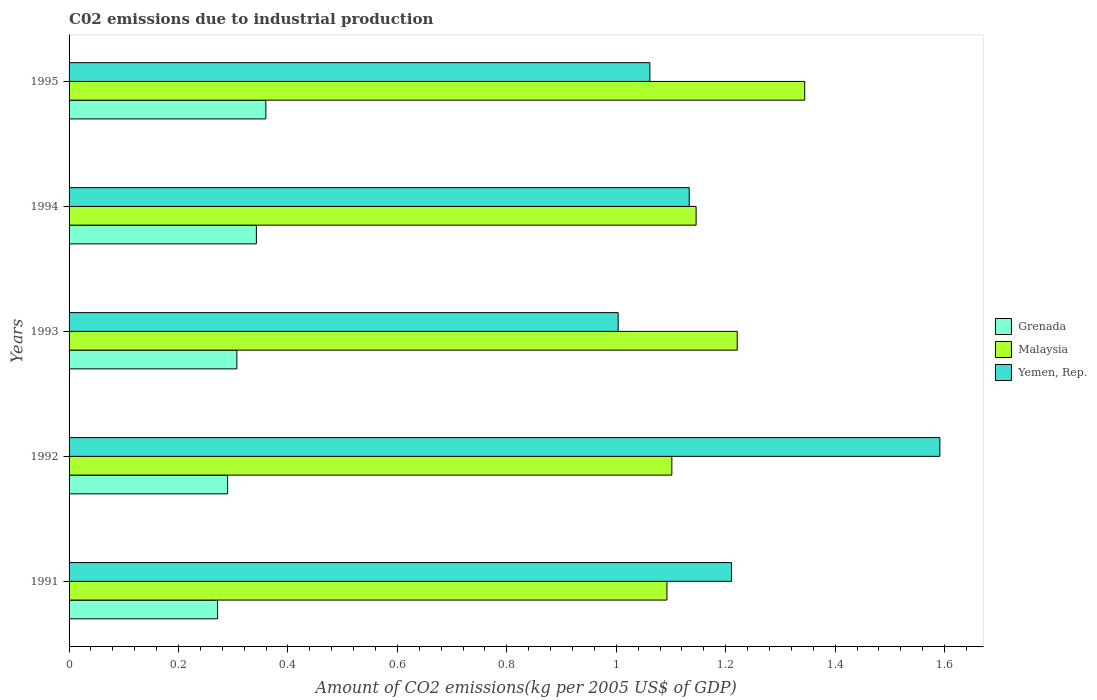Are the number of bars on each tick of the Y-axis equal?
Your answer should be compact. Yes. How many bars are there on the 1st tick from the top?
Your response must be concise. 3. What is the label of the 3rd group of bars from the top?
Provide a short and direct response. 1993. In how many cases, is the number of bars for a given year not equal to the number of legend labels?
Offer a terse response. 0. What is the amount of CO2 emitted due to industrial production in Grenada in 1994?
Offer a very short reply. 0.34. Across all years, what is the maximum amount of CO2 emitted due to industrial production in Yemen, Rep.?
Offer a terse response. 1.59. Across all years, what is the minimum amount of CO2 emitted due to industrial production in Malaysia?
Provide a short and direct response. 1.09. In which year was the amount of CO2 emitted due to industrial production in Yemen, Rep. maximum?
Your answer should be compact. 1992. What is the total amount of CO2 emitted due to industrial production in Grenada in the graph?
Offer a terse response. 1.57. What is the difference between the amount of CO2 emitted due to industrial production in Yemen, Rep. in 1992 and that in 1994?
Keep it short and to the point. 0.46. What is the difference between the amount of CO2 emitted due to industrial production in Grenada in 1993 and the amount of CO2 emitted due to industrial production in Malaysia in 1991?
Offer a terse response. -0.79. What is the average amount of CO2 emitted due to industrial production in Yemen, Rep. per year?
Your answer should be compact. 1.2. In the year 1995, what is the difference between the amount of CO2 emitted due to industrial production in Yemen, Rep. and amount of CO2 emitted due to industrial production in Grenada?
Make the answer very short. 0.7. What is the ratio of the amount of CO2 emitted due to industrial production in Grenada in 1992 to that in 1993?
Keep it short and to the point. 0.94. What is the difference between the highest and the second highest amount of CO2 emitted due to industrial production in Malaysia?
Keep it short and to the point. 0.12. What is the difference between the highest and the lowest amount of CO2 emitted due to industrial production in Malaysia?
Your response must be concise. 0.25. Is the sum of the amount of CO2 emitted due to industrial production in Grenada in 1992 and 1994 greater than the maximum amount of CO2 emitted due to industrial production in Yemen, Rep. across all years?
Make the answer very short. No. What does the 2nd bar from the top in 1995 represents?
Provide a succinct answer. Malaysia. What does the 3rd bar from the bottom in 1991 represents?
Offer a very short reply. Yemen, Rep. Is it the case that in every year, the sum of the amount of CO2 emitted due to industrial production in Malaysia and amount of CO2 emitted due to industrial production in Yemen, Rep. is greater than the amount of CO2 emitted due to industrial production in Grenada?
Give a very brief answer. Yes. How many bars are there?
Your answer should be compact. 15. How many years are there in the graph?
Your response must be concise. 5. Are the values on the major ticks of X-axis written in scientific E-notation?
Give a very brief answer. No. Does the graph contain any zero values?
Ensure brevity in your answer.  No. Where does the legend appear in the graph?
Offer a terse response. Center right. How are the legend labels stacked?
Provide a succinct answer. Vertical. What is the title of the graph?
Provide a short and direct response. C02 emissions due to industrial production. What is the label or title of the X-axis?
Ensure brevity in your answer.  Amount of CO2 emissions(kg per 2005 US$ of GDP). What is the Amount of CO2 emissions(kg per 2005 US$ of GDP) in Grenada in 1991?
Your answer should be compact. 0.27. What is the Amount of CO2 emissions(kg per 2005 US$ of GDP) of Malaysia in 1991?
Make the answer very short. 1.09. What is the Amount of CO2 emissions(kg per 2005 US$ of GDP) in Yemen, Rep. in 1991?
Your answer should be very brief. 1.21. What is the Amount of CO2 emissions(kg per 2005 US$ of GDP) of Grenada in 1992?
Give a very brief answer. 0.29. What is the Amount of CO2 emissions(kg per 2005 US$ of GDP) of Malaysia in 1992?
Your answer should be compact. 1.1. What is the Amount of CO2 emissions(kg per 2005 US$ of GDP) of Yemen, Rep. in 1992?
Give a very brief answer. 1.59. What is the Amount of CO2 emissions(kg per 2005 US$ of GDP) of Grenada in 1993?
Ensure brevity in your answer.  0.31. What is the Amount of CO2 emissions(kg per 2005 US$ of GDP) in Malaysia in 1993?
Provide a succinct answer. 1.22. What is the Amount of CO2 emissions(kg per 2005 US$ of GDP) in Yemen, Rep. in 1993?
Offer a terse response. 1. What is the Amount of CO2 emissions(kg per 2005 US$ of GDP) in Grenada in 1994?
Offer a very short reply. 0.34. What is the Amount of CO2 emissions(kg per 2005 US$ of GDP) in Malaysia in 1994?
Make the answer very short. 1.15. What is the Amount of CO2 emissions(kg per 2005 US$ of GDP) of Yemen, Rep. in 1994?
Your answer should be very brief. 1.13. What is the Amount of CO2 emissions(kg per 2005 US$ of GDP) of Grenada in 1995?
Ensure brevity in your answer.  0.36. What is the Amount of CO2 emissions(kg per 2005 US$ of GDP) in Malaysia in 1995?
Offer a terse response. 1.34. What is the Amount of CO2 emissions(kg per 2005 US$ of GDP) of Yemen, Rep. in 1995?
Your answer should be very brief. 1.06. Across all years, what is the maximum Amount of CO2 emissions(kg per 2005 US$ of GDP) in Grenada?
Your response must be concise. 0.36. Across all years, what is the maximum Amount of CO2 emissions(kg per 2005 US$ of GDP) in Malaysia?
Your response must be concise. 1.34. Across all years, what is the maximum Amount of CO2 emissions(kg per 2005 US$ of GDP) of Yemen, Rep.?
Keep it short and to the point. 1.59. Across all years, what is the minimum Amount of CO2 emissions(kg per 2005 US$ of GDP) in Grenada?
Keep it short and to the point. 0.27. Across all years, what is the minimum Amount of CO2 emissions(kg per 2005 US$ of GDP) in Malaysia?
Your response must be concise. 1.09. Across all years, what is the minimum Amount of CO2 emissions(kg per 2005 US$ of GDP) in Yemen, Rep.?
Ensure brevity in your answer.  1. What is the total Amount of CO2 emissions(kg per 2005 US$ of GDP) of Grenada in the graph?
Your response must be concise. 1.57. What is the total Amount of CO2 emissions(kg per 2005 US$ of GDP) in Malaysia in the graph?
Ensure brevity in your answer.  5.91. What is the total Amount of CO2 emissions(kg per 2005 US$ of GDP) of Yemen, Rep. in the graph?
Make the answer very short. 6. What is the difference between the Amount of CO2 emissions(kg per 2005 US$ of GDP) of Grenada in 1991 and that in 1992?
Your answer should be compact. -0.02. What is the difference between the Amount of CO2 emissions(kg per 2005 US$ of GDP) in Malaysia in 1991 and that in 1992?
Your answer should be very brief. -0.01. What is the difference between the Amount of CO2 emissions(kg per 2005 US$ of GDP) in Yemen, Rep. in 1991 and that in 1992?
Keep it short and to the point. -0.38. What is the difference between the Amount of CO2 emissions(kg per 2005 US$ of GDP) in Grenada in 1991 and that in 1993?
Provide a short and direct response. -0.04. What is the difference between the Amount of CO2 emissions(kg per 2005 US$ of GDP) of Malaysia in 1991 and that in 1993?
Provide a succinct answer. -0.13. What is the difference between the Amount of CO2 emissions(kg per 2005 US$ of GDP) of Yemen, Rep. in 1991 and that in 1993?
Make the answer very short. 0.21. What is the difference between the Amount of CO2 emissions(kg per 2005 US$ of GDP) in Grenada in 1991 and that in 1994?
Keep it short and to the point. -0.07. What is the difference between the Amount of CO2 emissions(kg per 2005 US$ of GDP) in Malaysia in 1991 and that in 1994?
Ensure brevity in your answer.  -0.05. What is the difference between the Amount of CO2 emissions(kg per 2005 US$ of GDP) in Yemen, Rep. in 1991 and that in 1994?
Your answer should be very brief. 0.08. What is the difference between the Amount of CO2 emissions(kg per 2005 US$ of GDP) in Grenada in 1991 and that in 1995?
Your response must be concise. -0.09. What is the difference between the Amount of CO2 emissions(kg per 2005 US$ of GDP) of Malaysia in 1991 and that in 1995?
Your response must be concise. -0.25. What is the difference between the Amount of CO2 emissions(kg per 2005 US$ of GDP) in Yemen, Rep. in 1991 and that in 1995?
Provide a succinct answer. 0.15. What is the difference between the Amount of CO2 emissions(kg per 2005 US$ of GDP) of Grenada in 1992 and that in 1993?
Give a very brief answer. -0.02. What is the difference between the Amount of CO2 emissions(kg per 2005 US$ of GDP) in Malaysia in 1992 and that in 1993?
Offer a very short reply. -0.12. What is the difference between the Amount of CO2 emissions(kg per 2005 US$ of GDP) of Yemen, Rep. in 1992 and that in 1993?
Ensure brevity in your answer.  0.59. What is the difference between the Amount of CO2 emissions(kg per 2005 US$ of GDP) of Grenada in 1992 and that in 1994?
Offer a very short reply. -0.05. What is the difference between the Amount of CO2 emissions(kg per 2005 US$ of GDP) in Malaysia in 1992 and that in 1994?
Your answer should be very brief. -0.04. What is the difference between the Amount of CO2 emissions(kg per 2005 US$ of GDP) in Yemen, Rep. in 1992 and that in 1994?
Your response must be concise. 0.46. What is the difference between the Amount of CO2 emissions(kg per 2005 US$ of GDP) of Grenada in 1992 and that in 1995?
Give a very brief answer. -0.07. What is the difference between the Amount of CO2 emissions(kg per 2005 US$ of GDP) in Malaysia in 1992 and that in 1995?
Offer a very short reply. -0.24. What is the difference between the Amount of CO2 emissions(kg per 2005 US$ of GDP) of Yemen, Rep. in 1992 and that in 1995?
Keep it short and to the point. 0.53. What is the difference between the Amount of CO2 emissions(kg per 2005 US$ of GDP) in Grenada in 1993 and that in 1994?
Your answer should be compact. -0.04. What is the difference between the Amount of CO2 emissions(kg per 2005 US$ of GDP) in Malaysia in 1993 and that in 1994?
Your answer should be compact. 0.08. What is the difference between the Amount of CO2 emissions(kg per 2005 US$ of GDP) of Yemen, Rep. in 1993 and that in 1994?
Provide a succinct answer. -0.13. What is the difference between the Amount of CO2 emissions(kg per 2005 US$ of GDP) of Grenada in 1993 and that in 1995?
Offer a very short reply. -0.05. What is the difference between the Amount of CO2 emissions(kg per 2005 US$ of GDP) in Malaysia in 1993 and that in 1995?
Give a very brief answer. -0.12. What is the difference between the Amount of CO2 emissions(kg per 2005 US$ of GDP) of Yemen, Rep. in 1993 and that in 1995?
Make the answer very short. -0.06. What is the difference between the Amount of CO2 emissions(kg per 2005 US$ of GDP) of Grenada in 1994 and that in 1995?
Your answer should be very brief. -0.02. What is the difference between the Amount of CO2 emissions(kg per 2005 US$ of GDP) of Malaysia in 1994 and that in 1995?
Provide a short and direct response. -0.2. What is the difference between the Amount of CO2 emissions(kg per 2005 US$ of GDP) in Yemen, Rep. in 1994 and that in 1995?
Your response must be concise. 0.07. What is the difference between the Amount of CO2 emissions(kg per 2005 US$ of GDP) of Grenada in 1991 and the Amount of CO2 emissions(kg per 2005 US$ of GDP) of Malaysia in 1992?
Offer a terse response. -0.83. What is the difference between the Amount of CO2 emissions(kg per 2005 US$ of GDP) in Grenada in 1991 and the Amount of CO2 emissions(kg per 2005 US$ of GDP) in Yemen, Rep. in 1992?
Your response must be concise. -1.32. What is the difference between the Amount of CO2 emissions(kg per 2005 US$ of GDP) of Malaysia in 1991 and the Amount of CO2 emissions(kg per 2005 US$ of GDP) of Yemen, Rep. in 1992?
Your response must be concise. -0.5. What is the difference between the Amount of CO2 emissions(kg per 2005 US$ of GDP) in Grenada in 1991 and the Amount of CO2 emissions(kg per 2005 US$ of GDP) in Malaysia in 1993?
Your answer should be very brief. -0.95. What is the difference between the Amount of CO2 emissions(kg per 2005 US$ of GDP) of Grenada in 1991 and the Amount of CO2 emissions(kg per 2005 US$ of GDP) of Yemen, Rep. in 1993?
Your response must be concise. -0.73. What is the difference between the Amount of CO2 emissions(kg per 2005 US$ of GDP) in Malaysia in 1991 and the Amount of CO2 emissions(kg per 2005 US$ of GDP) in Yemen, Rep. in 1993?
Your answer should be compact. 0.09. What is the difference between the Amount of CO2 emissions(kg per 2005 US$ of GDP) in Grenada in 1991 and the Amount of CO2 emissions(kg per 2005 US$ of GDP) in Malaysia in 1994?
Provide a short and direct response. -0.87. What is the difference between the Amount of CO2 emissions(kg per 2005 US$ of GDP) in Grenada in 1991 and the Amount of CO2 emissions(kg per 2005 US$ of GDP) in Yemen, Rep. in 1994?
Your response must be concise. -0.86. What is the difference between the Amount of CO2 emissions(kg per 2005 US$ of GDP) in Malaysia in 1991 and the Amount of CO2 emissions(kg per 2005 US$ of GDP) in Yemen, Rep. in 1994?
Provide a short and direct response. -0.04. What is the difference between the Amount of CO2 emissions(kg per 2005 US$ of GDP) of Grenada in 1991 and the Amount of CO2 emissions(kg per 2005 US$ of GDP) of Malaysia in 1995?
Your answer should be very brief. -1.07. What is the difference between the Amount of CO2 emissions(kg per 2005 US$ of GDP) in Grenada in 1991 and the Amount of CO2 emissions(kg per 2005 US$ of GDP) in Yemen, Rep. in 1995?
Offer a very short reply. -0.79. What is the difference between the Amount of CO2 emissions(kg per 2005 US$ of GDP) of Malaysia in 1991 and the Amount of CO2 emissions(kg per 2005 US$ of GDP) of Yemen, Rep. in 1995?
Make the answer very short. 0.03. What is the difference between the Amount of CO2 emissions(kg per 2005 US$ of GDP) in Grenada in 1992 and the Amount of CO2 emissions(kg per 2005 US$ of GDP) in Malaysia in 1993?
Give a very brief answer. -0.93. What is the difference between the Amount of CO2 emissions(kg per 2005 US$ of GDP) in Grenada in 1992 and the Amount of CO2 emissions(kg per 2005 US$ of GDP) in Yemen, Rep. in 1993?
Offer a terse response. -0.71. What is the difference between the Amount of CO2 emissions(kg per 2005 US$ of GDP) in Malaysia in 1992 and the Amount of CO2 emissions(kg per 2005 US$ of GDP) in Yemen, Rep. in 1993?
Provide a short and direct response. 0.1. What is the difference between the Amount of CO2 emissions(kg per 2005 US$ of GDP) in Grenada in 1992 and the Amount of CO2 emissions(kg per 2005 US$ of GDP) in Malaysia in 1994?
Offer a terse response. -0.86. What is the difference between the Amount of CO2 emissions(kg per 2005 US$ of GDP) in Grenada in 1992 and the Amount of CO2 emissions(kg per 2005 US$ of GDP) in Yemen, Rep. in 1994?
Ensure brevity in your answer.  -0.84. What is the difference between the Amount of CO2 emissions(kg per 2005 US$ of GDP) in Malaysia in 1992 and the Amount of CO2 emissions(kg per 2005 US$ of GDP) in Yemen, Rep. in 1994?
Your response must be concise. -0.03. What is the difference between the Amount of CO2 emissions(kg per 2005 US$ of GDP) in Grenada in 1992 and the Amount of CO2 emissions(kg per 2005 US$ of GDP) in Malaysia in 1995?
Provide a succinct answer. -1.05. What is the difference between the Amount of CO2 emissions(kg per 2005 US$ of GDP) in Grenada in 1992 and the Amount of CO2 emissions(kg per 2005 US$ of GDP) in Yemen, Rep. in 1995?
Offer a terse response. -0.77. What is the difference between the Amount of CO2 emissions(kg per 2005 US$ of GDP) of Malaysia in 1992 and the Amount of CO2 emissions(kg per 2005 US$ of GDP) of Yemen, Rep. in 1995?
Give a very brief answer. 0.04. What is the difference between the Amount of CO2 emissions(kg per 2005 US$ of GDP) in Grenada in 1993 and the Amount of CO2 emissions(kg per 2005 US$ of GDP) in Malaysia in 1994?
Provide a short and direct response. -0.84. What is the difference between the Amount of CO2 emissions(kg per 2005 US$ of GDP) of Grenada in 1993 and the Amount of CO2 emissions(kg per 2005 US$ of GDP) of Yemen, Rep. in 1994?
Your response must be concise. -0.83. What is the difference between the Amount of CO2 emissions(kg per 2005 US$ of GDP) in Malaysia in 1993 and the Amount of CO2 emissions(kg per 2005 US$ of GDP) in Yemen, Rep. in 1994?
Make the answer very short. 0.09. What is the difference between the Amount of CO2 emissions(kg per 2005 US$ of GDP) in Grenada in 1993 and the Amount of CO2 emissions(kg per 2005 US$ of GDP) in Malaysia in 1995?
Your answer should be very brief. -1.04. What is the difference between the Amount of CO2 emissions(kg per 2005 US$ of GDP) in Grenada in 1993 and the Amount of CO2 emissions(kg per 2005 US$ of GDP) in Yemen, Rep. in 1995?
Offer a very short reply. -0.75. What is the difference between the Amount of CO2 emissions(kg per 2005 US$ of GDP) in Malaysia in 1993 and the Amount of CO2 emissions(kg per 2005 US$ of GDP) in Yemen, Rep. in 1995?
Provide a succinct answer. 0.16. What is the difference between the Amount of CO2 emissions(kg per 2005 US$ of GDP) of Grenada in 1994 and the Amount of CO2 emissions(kg per 2005 US$ of GDP) of Malaysia in 1995?
Make the answer very short. -1. What is the difference between the Amount of CO2 emissions(kg per 2005 US$ of GDP) of Grenada in 1994 and the Amount of CO2 emissions(kg per 2005 US$ of GDP) of Yemen, Rep. in 1995?
Offer a very short reply. -0.72. What is the difference between the Amount of CO2 emissions(kg per 2005 US$ of GDP) in Malaysia in 1994 and the Amount of CO2 emissions(kg per 2005 US$ of GDP) in Yemen, Rep. in 1995?
Provide a succinct answer. 0.08. What is the average Amount of CO2 emissions(kg per 2005 US$ of GDP) of Grenada per year?
Offer a very short reply. 0.31. What is the average Amount of CO2 emissions(kg per 2005 US$ of GDP) in Malaysia per year?
Ensure brevity in your answer.  1.18. What is the average Amount of CO2 emissions(kg per 2005 US$ of GDP) in Yemen, Rep. per year?
Keep it short and to the point. 1.2. In the year 1991, what is the difference between the Amount of CO2 emissions(kg per 2005 US$ of GDP) of Grenada and Amount of CO2 emissions(kg per 2005 US$ of GDP) of Malaysia?
Give a very brief answer. -0.82. In the year 1991, what is the difference between the Amount of CO2 emissions(kg per 2005 US$ of GDP) in Grenada and Amount of CO2 emissions(kg per 2005 US$ of GDP) in Yemen, Rep.?
Your answer should be very brief. -0.94. In the year 1991, what is the difference between the Amount of CO2 emissions(kg per 2005 US$ of GDP) in Malaysia and Amount of CO2 emissions(kg per 2005 US$ of GDP) in Yemen, Rep.?
Provide a succinct answer. -0.12. In the year 1992, what is the difference between the Amount of CO2 emissions(kg per 2005 US$ of GDP) of Grenada and Amount of CO2 emissions(kg per 2005 US$ of GDP) of Malaysia?
Give a very brief answer. -0.81. In the year 1992, what is the difference between the Amount of CO2 emissions(kg per 2005 US$ of GDP) in Grenada and Amount of CO2 emissions(kg per 2005 US$ of GDP) in Yemen, Rep.?
Provide a short and direct response. -1.3. In the year 1992, what is the difference between the Amount of CO2 emissions(kg per 2005 US$ of GDP) in Malaysia and Amount of CO2 emissions(kg per 2005 US$ of GDP) in Yemen, Rep.?
Give a very brief answer. -0.49. In the year 1993, what is the difference between the Amount of CO2 emissions(kg per 2005 US$ of GDP) of Grenada and Amount of CO2 emissions(kg per 2005 US$ of GDP) of Malaysia?
Offer a terse response. -0.91. In the year 1993, what is the difference between the Amount of CO2 emissions(kg per 2005 US$ of GDP) in Grenada and Amount of CO2 emissions(kg per 2005 US$ of GDP) in Yemen, Rep.?
Your response must be concise. -0.7. In the year 1993, what is the difference between the Amount of CO2 emissions(kg per 2005 US$ of GDP) of Malaysia and Amount of CO2 emissions(kg per 2005 US$ of GDP) of Yemen, Rep.?
Give a very brief answer. 0.22. In the year 1994, what is the difference between the Amount of CO2 emissions(kg per 2005 US$ of GDP) in Grenada and Amount of CO2 emissions(kg per 2005 US$ of GDP) in Malaysia?
Make the answer very short. -0.8. In the year 1994, what is the difference between the Amount of CO2 emissions(kg per 2005 US$ of GDP) of Grenada and Amount of CO2 emissions(kg per 2005 US$ of GDP) of Yemen, Rep.?
Provide a short and direct response. -0.79. In the year 1994, what is the difference between the Amount of CO2 emissions(kg per 2005 US$ of GDP) of Malaysia and Amount of CO2 emissions(kg per 2005 US$ of GDP) of Yemen, Rep.?
Offer a very short reply. 0.01. In the year 1995, what is the difference between the Amount of CO2 emissions(kg per 2005 US$ of GDP) of Grenada and Amount of CO2 emissions(kg per 2005 US$ of GDP) of Malaysia?
Ensure brevity in your answer.  -0.98. In the year 1995, what is the difference between the Amount of CO2 emissions(kg per 2005 US$ of GDP) of Grenada and Amount of CO2 emissions(kg per 2005 US$ of GDP) of Yemen, Rep.?
Ensure brevity in your answer.  -0.7. In the year 1995, what is the difference between the Amount of CO2 emissions(kg per 2005 US$ of GDP) in Malaysia and Amount of CO2 emissions(kg per 2005 US$ of GDP) in Yemen, Rep.?
Your response must be concise. 0.28. What is the ratio of the Amount of CO2 emissions(kg per 2005 US$ of GDP) in Grenada in 1991 to that in 1992?
Ensure brevity in your answer.  0.94. What is the ratio of the Amount of CO2 emissions(kg per 2005 US$ of GDP) in Yemen, Rep. in 1991 to that in 1992?
Give a very brief answer. 0.76. What is the ratio of the Amount of CO2 emissions(kg per 2005 US$ of GDP) in Grenada in 1991 to that in 1993?
Your response must be concise. 0.89. What is the ratio of the Amount of CO2 emissions(kg per 2005 US$ of GDP) in Malaysia in 1991 to that in 1993?
Offer a very short reply. 0.89. What is the ratio of the Amount of CO2 emissions(kg per 2005 US$ of GDP) of Yemen, Rep. in 1991 to that in 1993?
Give a very brief answer. 1.21. What is the ratio of the Amount of CO2 emissions(kg per 2005 US$ of GDP) of Grenada in 1991 to that in 1994?
Your answer should be very brief. 0.79. What is the ratio of the Amount of CO2 emissions(kg per 2005 US$ of GDP) of Malaysia in 1991 to that in 1994?
Give a very brief answer. 0.95. What is the ratio of the Amount of CO2 emissions(kg per 2005 US$ of GDP) of Yemen, Rep. in 1991 to that in 1994?
Your response must be concise. 1.07. What is the ratio of the Amount of CO2 emissions(kg per 2005 US$ of GDP) of Grenada in 1991 to that in 1995?
Provide a succinct answer. 0.75. What is the ratio of the Amount of CO2 emissions(kg per 2005 US$ of GDP) in Malaysia in 1991 to that in 1995?
Ensure brevity in your answer.  0.81. What is the ratio of the Amount of CO2 emissions(kg per 2005 US$ of GDP) of Yemen, Rep. in 1991 to that in 1995?
Ensure brevity in your answer.  1.14. What is the ratio of the Amount of CO2 emissions(kg per 2005 US$ of GDP) of Grenada in 1992 to that in 1993?
Make the answer very short. 0.94. What is the ratio of the Amount of CO2 emissions(kg per 2005 US$ of GDP) of Malaysia in 1992 to that in 1993?
Provide a succinct answer. 0.9. What is the ratio of the Amount of CO2 emissions(kg per 2005 US$ of GDP) of Yemen, Rep. in 1992 to that in 1993?
Offer a terse response. 1.59. What is the ratio of the Amount of CO2 emissions(kg per 2005 US$ of GDP) in Grenada in 1992 to that in 1994?
Ensure brevity in your answer.  0.85. What is the ratio of the Amount of CO2 emissions(kg per 2005 US$ of GDP) in Malaysia in 1992 to that in 1994?
Your response must be concise. 0.96. What is the ratio of the Amount of CO2 emissions(kg per 2005 US$ of GDP) in Yemen, Rep. in 1992 to that in 1994?
Your answer should be compact. 1.4. What is the ratio of the Amount of CO2 emissions(kg per 2005 US$ of GDP) of Grenada in 1992 to that in 1995?
Give a very brief answer. 0.81. What is the ratio of the Amount of CO2 emissions(kg per 2005 US$ of GDP) in Malaysia in 1992 to that in 1995?
Offer a very short reply. 0.82. What is the ratio of the Amount of CO2 emissions(kg per 2005 US$ of GDP) in Yemen, Rep. in 1992 to that in 1995?
Provide a succinct answer. 1.5. What is the ratio of the Amount of CO2 emissions(kg per 2005 US$ of GDP) in Grenada in 1993 to that in 1994?
Your answer should be compact. 0.9. What is the ratio of the Amount of CO2 emissions(kg per 2005 US$ of GDP) in Malaysia in 1993 to that in 1994?
Offer a very short reply. 1.07. What is the ratio of the Amount of CO2 emissions(kg per 2005 US$ of GDP) of Yemen, Rep. in 1993 to that in 1994?
Keep it short and to the point. 0.89. What is the ratio of the Amount of CO2 emissions(kg per 2005 US$ of GDP) of Grenada in 1993 to that in 1995?
Make the answer very short. 0.85. What is the ratio of the Amount of CO2 emissions(kg per 2005 US$ of GDP) of Malaysia in 1993 to that in 1995?
Your response must be concise. 0.91. What is the ratio of the Amount of CO2 emissions(kg per 2005 US$ of GDP) of Yemen, Rep. in 1993 to that in 1995?
Keep it short and to the point. 0.95. What is the ratio of the Amount of CO2 emissions(kg per 2005 US$ of GDP) of Grenada in 1994 to that in 1995?
Ensure brevity in your answer.  0.95. What is the ratio of the Amount of CO2 emissions(kg per 2005 US$ of GDP) in Malaysia in 1994 to that in 1995?
Ensure brevity in your answer.  0.85. What is the ratio of the Amount of CO2 emissions(kg per 2005 US$ of GDP) in Yemen, Rep. in 1994 to that in 1995?
Your answer should be compact. 1.07. What is the difference between the highest and the second highest Amount of CO2 emissions(kg per 2005 US$ of GDP) of Grenada?
Your response must be concise. 0.02. What is the difference between the highest and the second highest Amount of CO2 emissions(kg per 2005 US$ of GDP) of Malaysia?
Make the answer very short. 0.12. What is the difference between the highest and the second highest Amount of CO2 emissions(kg per 2005 US$ of GDP) in Yemen, Rep.?
Your answer should be very brief. 0.38. What is the difference between the highest and the lowest Amount of CO2 emissions(kg per 2005 US$ of GDP) in Grenada?
Keep it short and to the point. 0.09. What is the difference between the highest and the lowest Amount of CO2 emissions(kg per 2005 US$ of GDP) in Malaysia?
Make the answer very short. 0.25. What is the difference between the highest and the lowest Amount of CO2 emissions(kg per 2005 US$ of GDP) of Yemen, Rep.?
Offer a terse response. 0.59. 